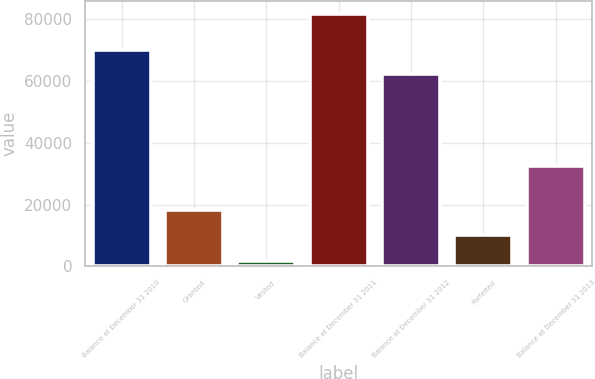Convert chart to OTSL. <chart><loc_0><loc_0><loc_500><loc_500><bar_chart><fcel>Balance at December 31 2010<fcel>Granted<fcel>Vested<fcel>Balance at December 31 2011<fcel>Balance at December 31 2012<fcel>Forfeited<fcel>Balance at December 31 2013<nl><fcel>70253.5<fcel>18317.5<fcel>1600<fcel>81845<fcel>62229<fcel>10293<fcel>32541<nl></chart> 